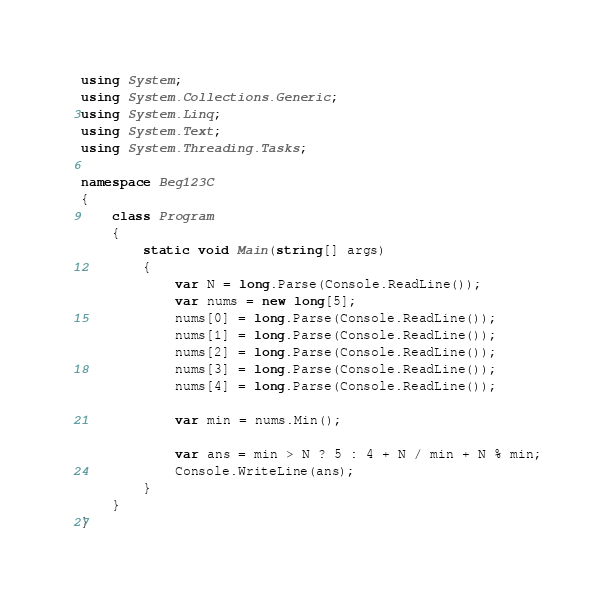<code> <loc_0><loc_0><loc_500><loc_500><_C#_>using System;
using System.Collections.Generic;
using System.Linq;
using System.Text;
using System.Threading.Tasks;

namespace Beg123C
{
    class Program
    {
        static void Main(string[] args)
        {
            var N = long.Parse(Console.ReadLine());
            var nums = new long[5];
            nums[0] = long.Parse(Console.ReadLine());
            nums[1] = long.Parse(Console.ReadLine());
            nums[2] = long.Parse(Console.ReadLine());
            nums[3] = long.Parse(Console.ReadLine());
            nums[4] = long.Parse(Console.ReadLine());

            var min = nums.Min();

            var ans = min > N ? 5 : 4 + N / min + N % min;
            Console.WriteLine(ans);
        }
    }
}
</code> 